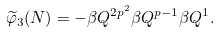Convert formula to latex. <formula><loc_0><loc_0><loc_500><loc_500>\widetilde { \varphi } _ { 3 } ( N ) = - \beta Q ^ { 2 p ^ { 2 } } \beta Q ^ { p - 1 } \beta Q ^ { 1 } .</formula> 